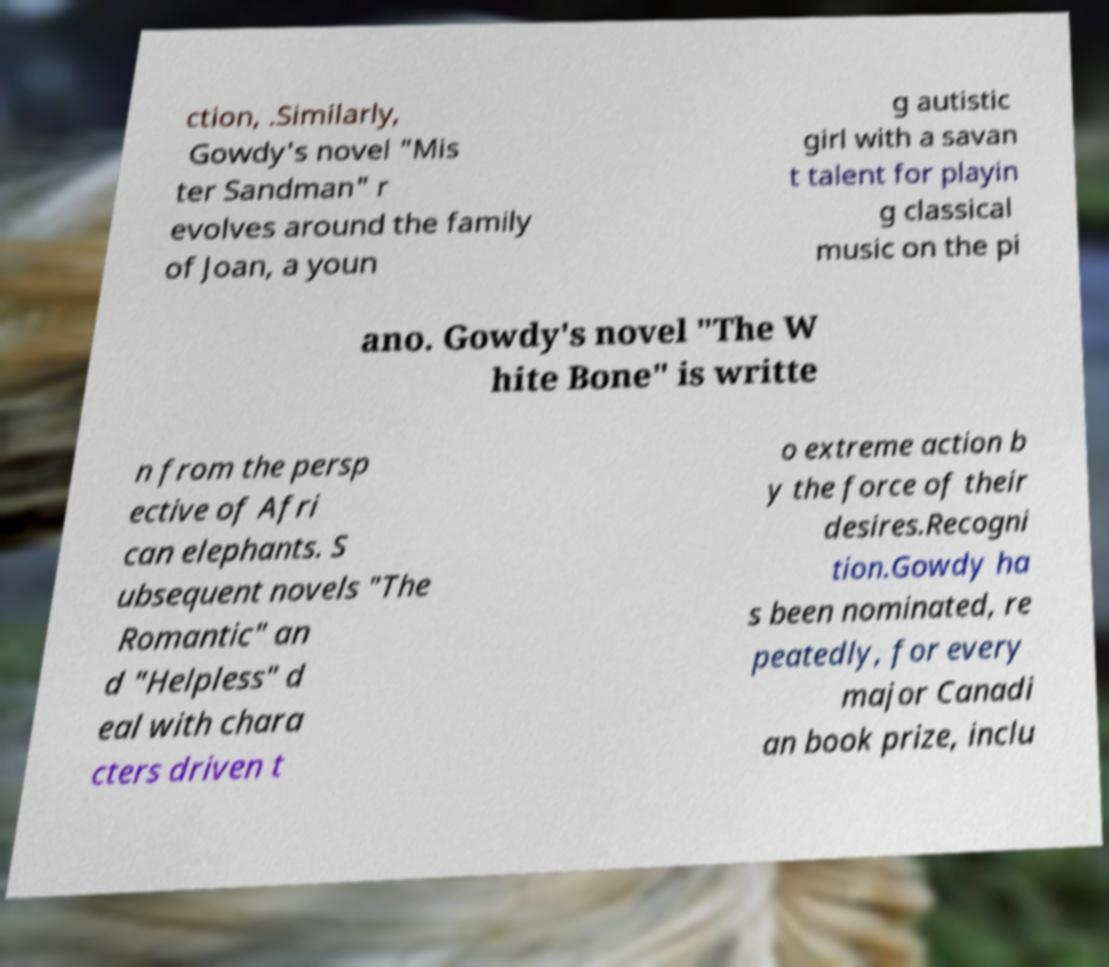Could you extract and type out the text from this image? ction, .Similarly, Gowdy's novel "Mis ter Sandman" r evolves around the family of Joan, a youn g autistic girl with a savan t talent for playin g classical music on the pi ano. Gowdy's novel "The W hite Bone" is writte n from the persp ective of Afri can elephants. S ubsequent novels "The Romantic" an d "Helpless" d eal with chara cters driven t o extreme action b y the force of their desires.Recogni tion.Gowdy ha s been nominated, re peatedly, for every major Canadi an book prize, inclu 